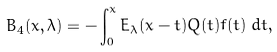Convert formula to latex. <formula><loc_0><loc_0><loc_500><loc_500>B _ { 4 } ( x , \lambda ) = - \int _ { 0 } ^ { x } E _ { \lambda } ( x - t ) Q ( t ) f ( t ) \, d t ,</formula> 